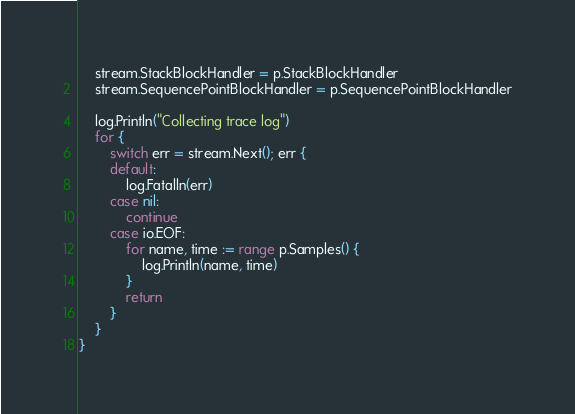Convert code to text. <code><loc_0><loc_0><loc_500><loc_500><_Go_>	stream.StackBlockHandler = p.StackBlockHandler
	stream.SequencePointBlockHandler = p.SequencePointBlockHandler

	log.Println("Collecting trace log")
	for {
		switch err = stream.Next(); err {
		default:
			log.Fatalln(err)
		case nil:
			continue
		case io.EOF:
			for name, time := range p.Samples() {
				log.Println(name, time)
			}
			return
		}
	}
}
</code> 